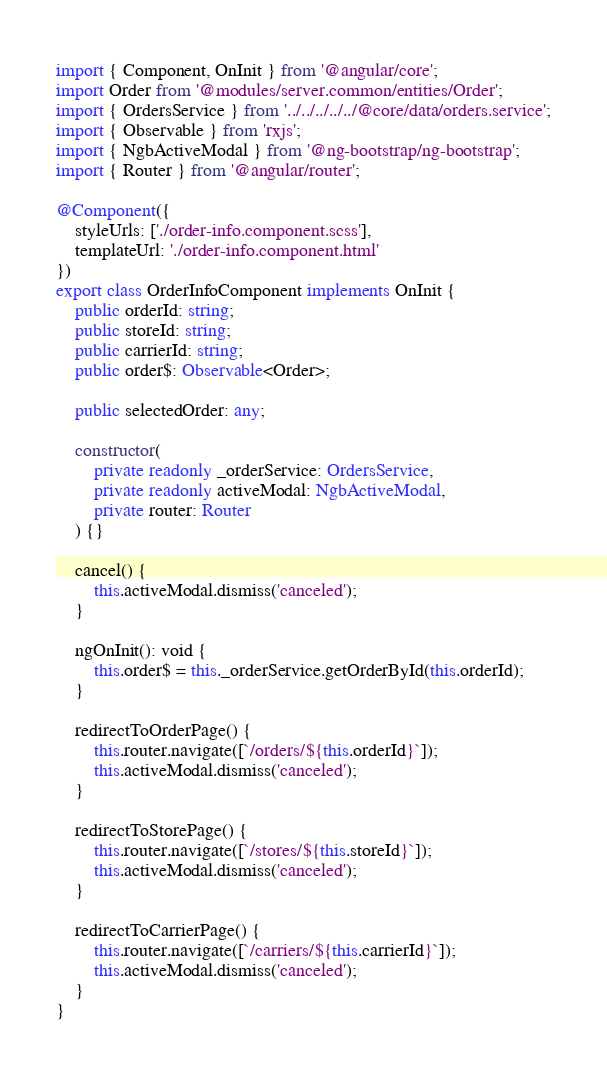Convert code to text. <code><loc_0><loc_0><loc_500><loc_500><_TypeScript_>import { Component, OnInit } from '@angular/core';
import Order from '@modules/server.common/entities/Order';
import { OrdersService } from '../../../../../@core/data/orders.service';
import { Observable } from 'rxjs';
import { NgbActiveModal } from '@ng-bootstrap/ng-bootstrap';
import { Router } from '@angular/router';

@Component({
	styleUrls: ['./order-info.component.scss'],
	templateUrl: './order-info.component.html'
})
export class OrderInfoComponent implements OnInit {
	public orderId: string;
	public storeId: string;
	public carrierId: string;
	public order$: Observable<Order>;

	public selectedOrder: any;

	constructor(
		private readonly _orderService: OrdersService,
		private readonly activeModal: NgbActiveModal,
		private router: Router
	) {}

	cancel() {
		this.activeModal.dismiss('canceled');
	}

	ngOnInit(): void {
		this.order$ = this._orderService.getOrderById(this.orderId);
	}

	redirectToOrderPage() {
		this.router.navigate([`/orders/${this.orderId}`]);
		this.activeModal.dismiss('canceled');
	}

	redirectToStorePage() {
		this.router.navigate([`/stores/${this.storeId}`]);
		this.activeModal.dismiss('canceled');
	}

	redirectToCarrierPage() {
		this.router.navigate([`/carriers/${this.carrierId}`]);
		this.activeModal.dismiss('canceled');
	}
}
</code> 